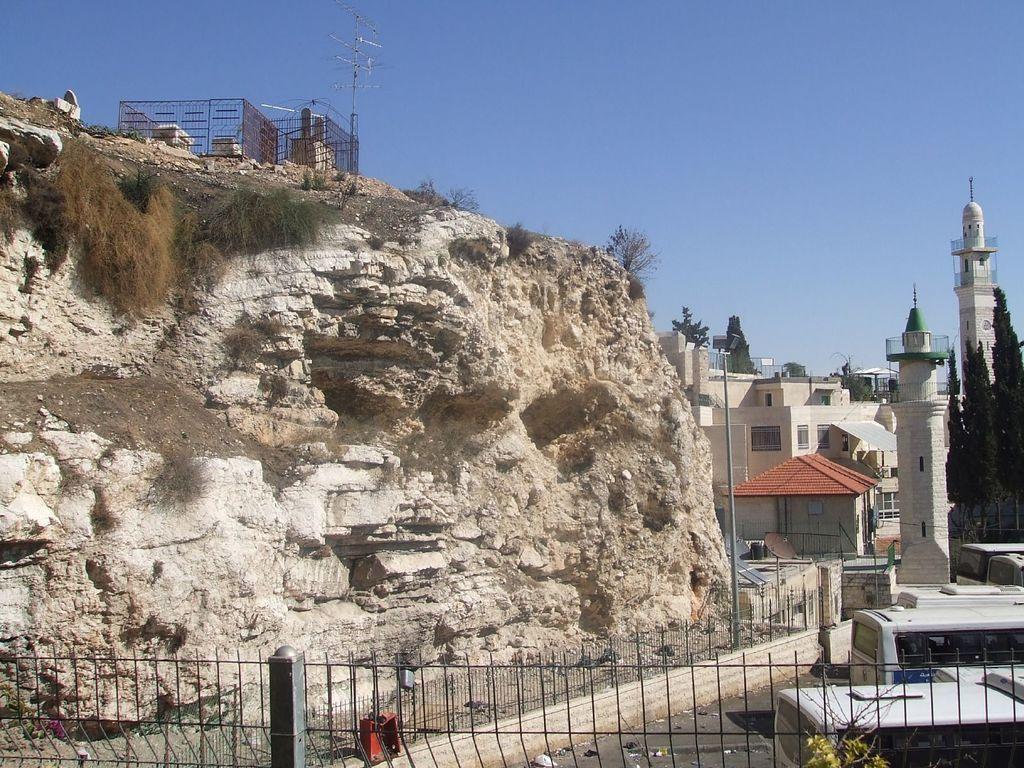Describe this image in one or two sentences. In this picture we can see the buildings, trees, poles, mesh, rock, plants. At the bottom of the image we can see the grilles, road, buses. At the top of the image we can see the sky. 